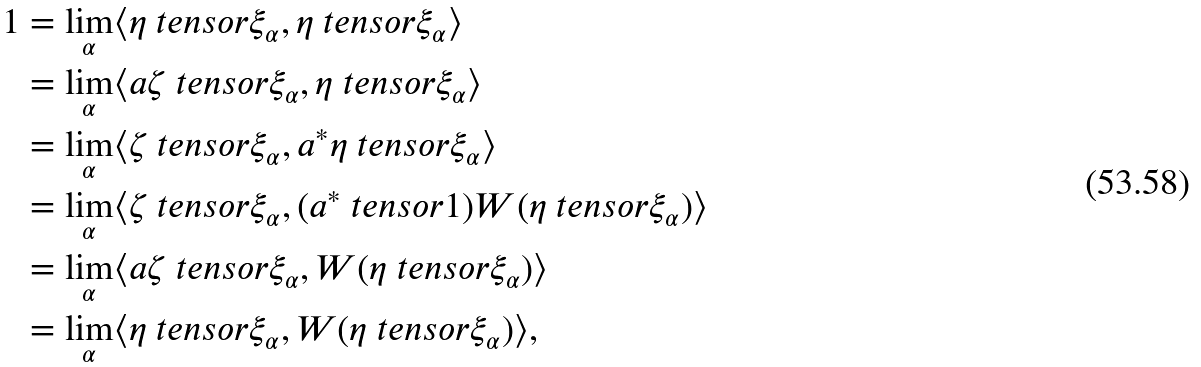Convert formula to latex. <formula><loc_0><loc_0><loc_500><loc_500>1 & = \lim _ { \alpha } \langle \eta \ t e n s o r \xi _ { \alpha } , \eta \ t e n s o r \xi _ { \alpha } \rangle \\ & = \lim _ { \alpha } \langle a \zeta \ t e n s o r \xi _ { \alpha } , \eta \ t e n s o r \xi _ { \alpha } \rangle \\ & = \lim _ { \alpha } \langle \zeta \ t e n s o r \xi _ { \alpha } , a ^ { \ast } \eta \ t e n s o r \xi _ { \alpha } \rangle \\ & = \lim _ { \alpha } \langle \zeta \ t e n s o r \xi _ { \alpha } , ( a ^ { \ast } \ t e n s o r 1 ) W ( \eta \ t e n s o r \xi _ { \alpha } ) \rangle \\ & = \lim _ { \alpha } \langle a \zeta \ t e n s o r \xi _ { \alpha } , W ( \eta \ t e n s o r \xi _ { \alpha } ) \rangle \\ & = \lim _ { \alpha } \langle \eta \ t e n s o r \xi _ { \alpha } , W ( \eta \ t e n s o r \xi _ { \alpha } ) \rangle ,</formula> 